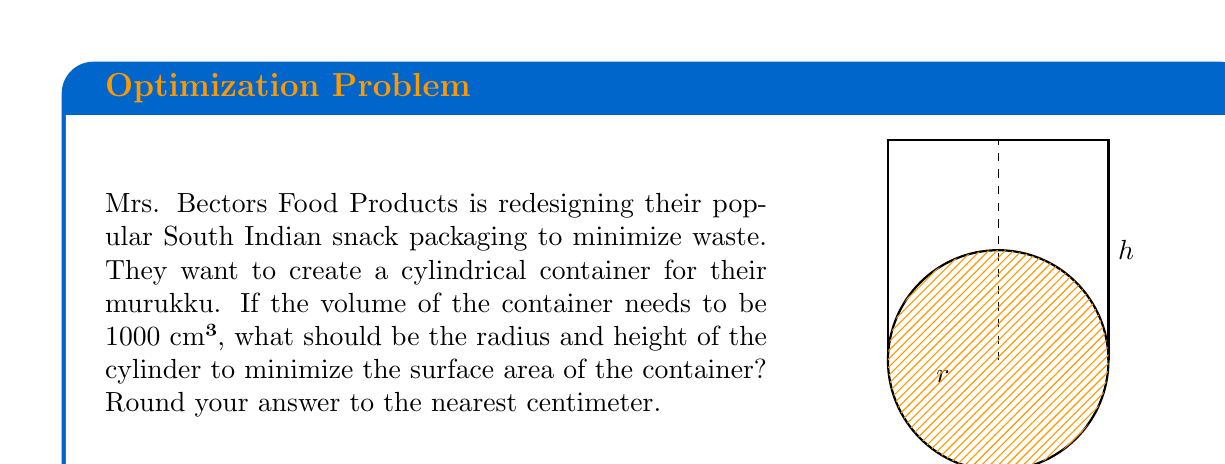Show me your answer to this math problem. Let's approach this step-by-step:

1) The volume of a cylinder is given by $V = \pi r^2 h$, where $r$ is the radius and $h$ is the height.

2) We're told that the volume needs to be 1000 cm³, so:

   $$1000 = \pi r^2 h$$

3) The surface area of a cylinder (including top and bottom) is given by:

   $$S = 2\pi r^2 + 2\pi r h$$

4) We want to minimize $S$. We can express $h$ in terms of $r$ using the volume equation:

   $$h = \frac{1000}{\pi r^2}$$

5) Substituting this into the surface area equation:

   $$S = 2\pi r^2 + 2\pi r (\frac{1000}{\pi r^2}) = 2\pi r^2 + \frac{2000}{r}$$

6) To find the minimum, we differentiate $S$ with respect to $r$ and set it to zero:

   $$\frac{dS}{dr} = 4\pi r - \frac{2000}{r^2} = 0$$

7) Solving this equation:

   $$4\pi r^3 = 2000$$
   $$r^3 = \frac{500}{\pi}$$
   $$r = \sqrt[3]{\frac{500}{\pi}} \approx 5.4 \text{ cm}$$

8) We can find $h$ using the volume equation:

   $$h = \frac{1000}{\pi r^2} \approx 10.8 \text{ cm}$$

9) Rounding to the nearest centimeter:

   $r = 5 \text{ cm}$ and $h = 11 \text{ cm}$
Answer: $r = 5 \text{ cm}, h = 11 \text{ cm}$ 